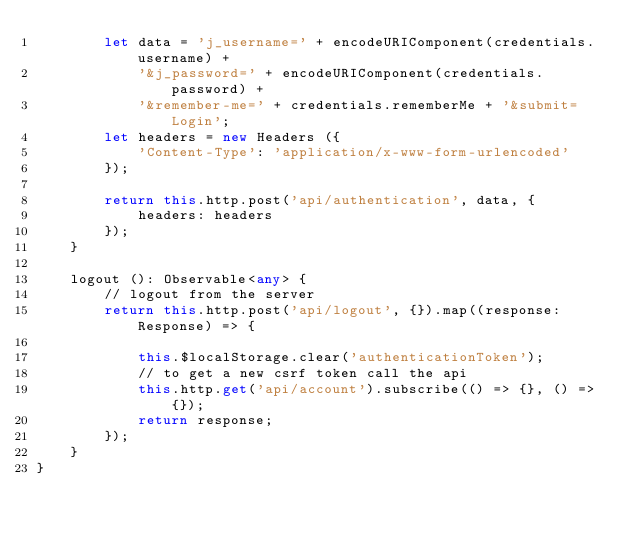<code> <loc_0><loc_0><loc_500><loc_500><_TypeScript_>        let data = 'j_username=' + encodeURIComponent(credentials.username) +
            '&j_password=' + encodeURIComponent(credentials.password) +
            '&remember-me=' + credentials.rememberMe + '&submit=Login';
        let headers = new Headers ({
            'Content-Type': 'application/x-www-form-urlencoded'
        });

        return this.http.post('api/authentication', data, {
            headers: headers
        });
    }

    logout (): Observable<any> {
        // logout from the server
        return this.http.post('api/logout', {}).map((response: Response) => {

            this.$localStorage.clear('authenticationToken');
            // to get a new csrf token call the api
            this.http.get('api/account').subscribe(() => {}, () => {});
            return response;
        });
    }
}
</code> 